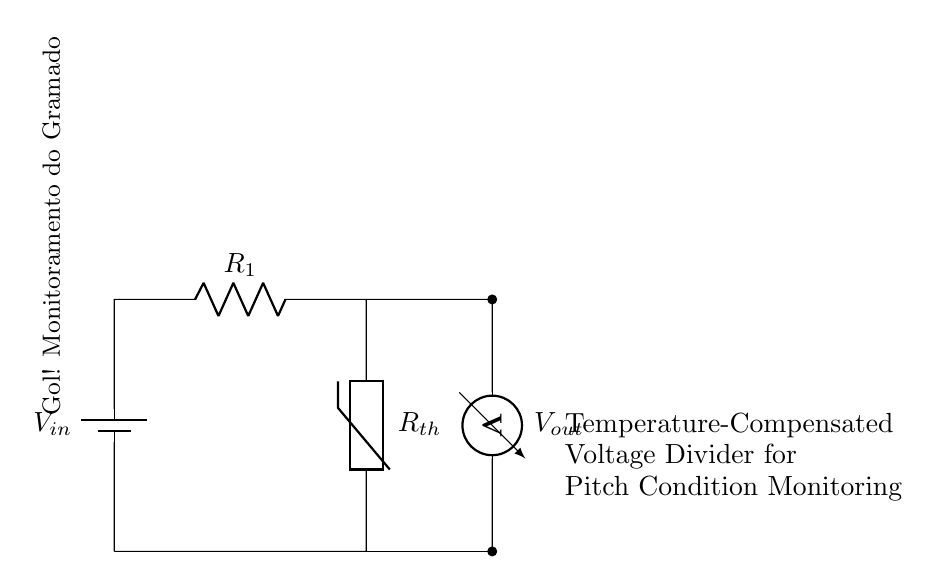What is the input voltage in this circuit? The input voltage, indicated as \( V_{in} \), is connected to the top of the resistor \( R_1 \) and is the source voltage for the divider.
Answer: \( V_{in} \) What type of resistor is \( R_{th} \)? \( R_{th} \) is labeled as a thermistor, which is a temperature-sensitive resistor that changes its resistance with temperature.
Answer: Thermistor How many resistive elements are in the circuit? There are two resistive elements in the circuit: \( R_1 \) and \( R_{th} \). They form the voltage divider.
Answer: Two What is the purpose of the voltage divider in this case? The purpose of the voltage divider is to monitor pitch conditions by providing a voltage output that varies according to temperature changes sensed by the thermistor.
Answer: Pitch condition monitoring If the temperature increases, what happens to \( V_{out} \)? As the temperature increases, the resistance of the thermistor \( R_{th} \) decreases, which causes \( V_{out} \) to change based on the voltage division principle. Specifically, \( V_{out} \) will increase as a result.
Answer: \( V_{out} \) increases What does the voltmeter measure? The voltmeter measures the output voltage \( V_{out} \), which is the voltage across the thermistor and indicates the state of the temperature compensation in the divider circuit.
Answer: \( V_{out} \) 